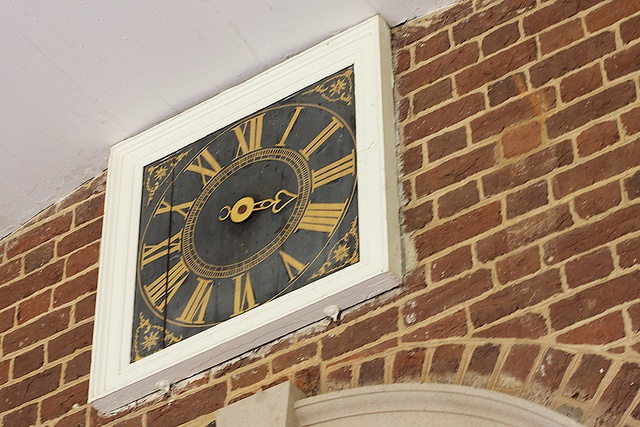Describe the objects in this image and their specific colors. I can see a clock in lightgray, gray, tan, and black tones in this image. 